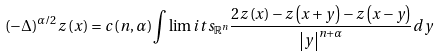<formula> <loc_0><loc_0><loc_500><loc_500>( - \Delta ) ^ { \alpha / 2 } z \left ( x \right ) = c \left ( n , \alpha \right ) \int \lim i t s _ { \mathbb { R } ^ { n } } \frac { 2 z \left ( x \right ) - z \left ( x + y \right ) - z \left ( x - y \right ) } { \left | y \right | ^ { n + \alpha } } d y</formula> 